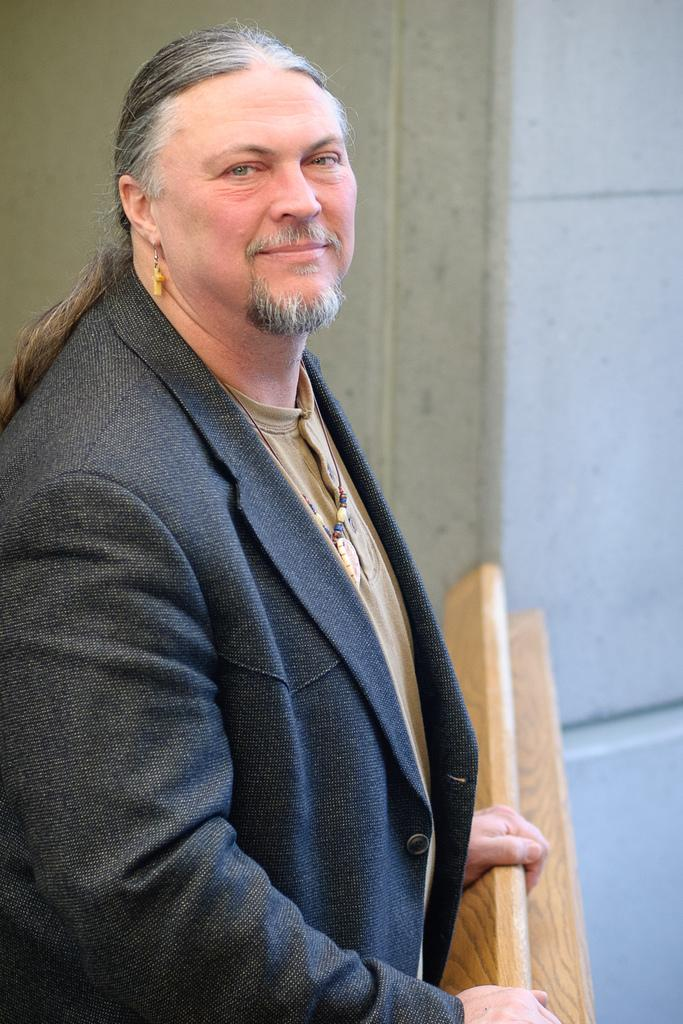What is the main subject of the image? There is a person standing in the image. What is the person holding in the image? The person is holding an object. What can be seen in the background of the image? There is a wall in the background of the image. What type of silk is being used to paint the wall in the image? There is no silk or painting activity present in the image. 